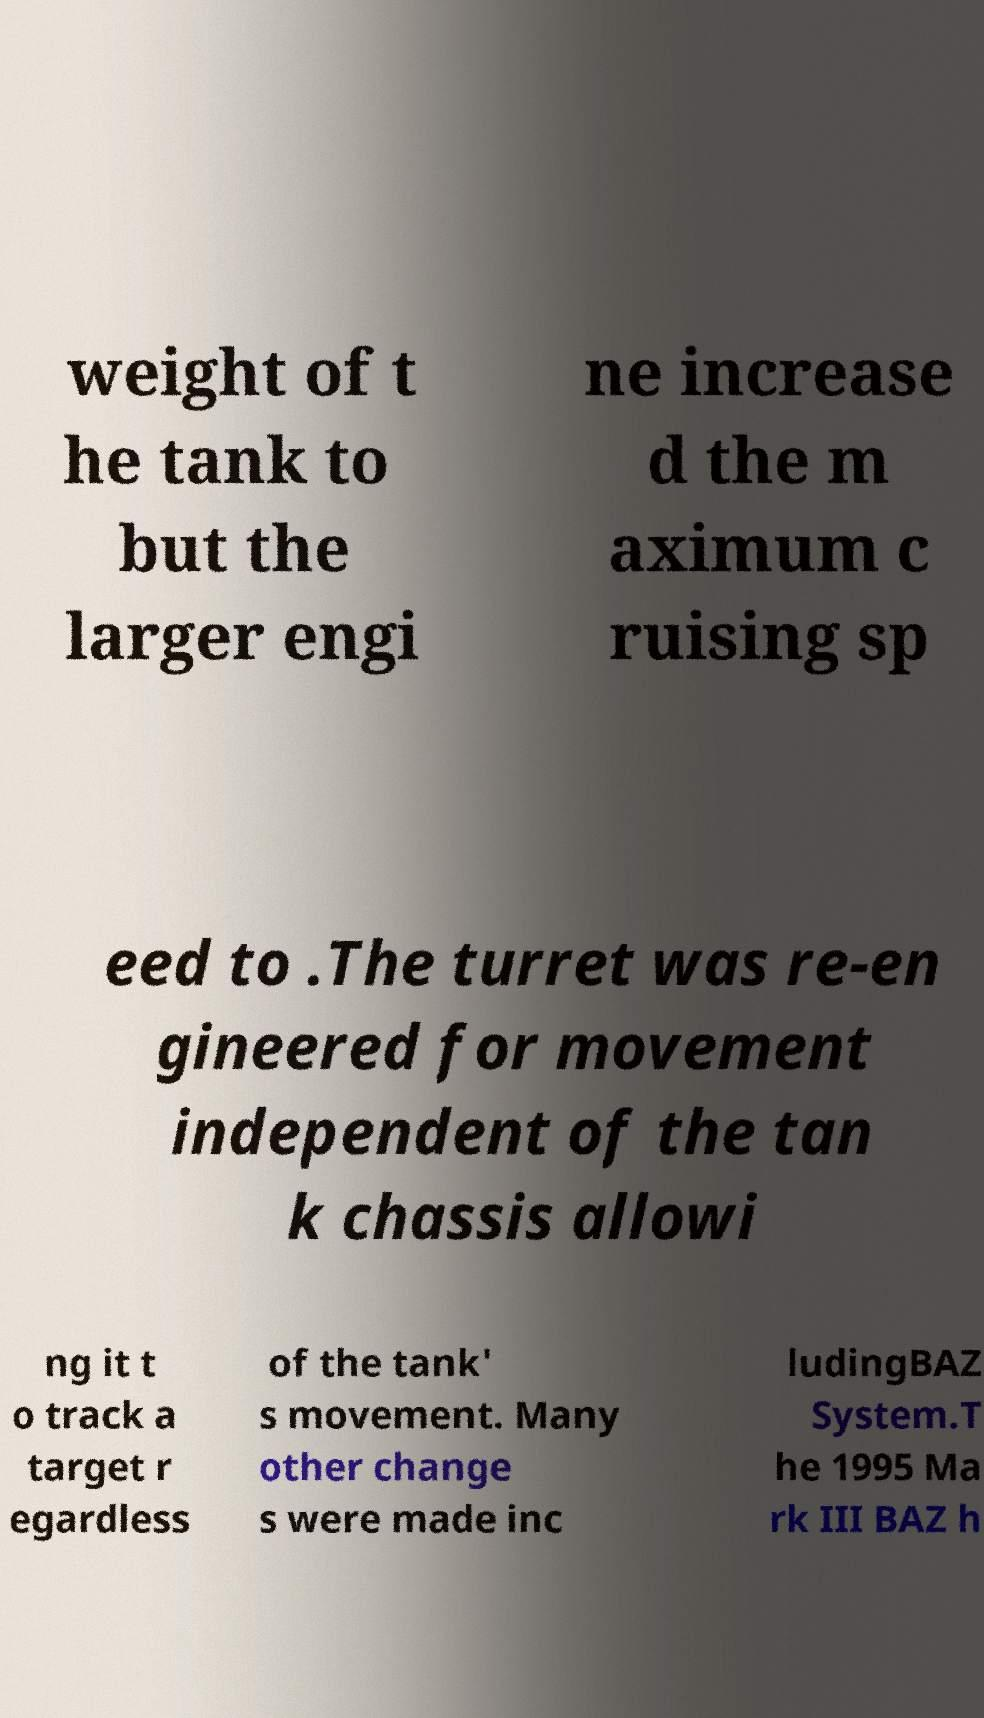Can you read and provide the text displayed in the image?This photo seems to have some interesting text. Can you extract and type it out for me? weight of t he tank to but the larger engi ne increase d the m aximum c ruising sp eed to .The turret was re-en gineered for movement independent of the tan k chassis allowi ng it t o track a target r egardless of the tank' s movement. Many other change s were made inc ludingBAZ System.T he 1995 Ma rk III BAZ h 